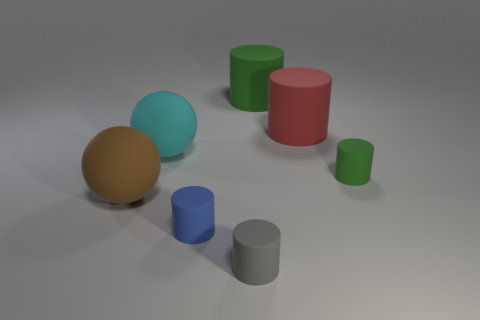How big is the matte cylinder that is in front of the matte cylinder to the left of the small rubber cylinder that is in front of the blue matte thing?
Give a very brief answer. Small. What is the material of the brown object that is the same size as the cyan thing?
Make the answer very short. Rubber. Are there any cylinders that have the same size as the gray matte object?
Offer a terse response. Yes. Does the green matte object that is right of the red rubber cylinder have the same size as the tiny blue matte thing?
Make the answer very short. Yes. There is a rubber thing that is both on the right side of the small gray rubber thing and in front of the large cyan matte object; what shape is it?
Offer a terse response. Cylinder. Are there more small blue matte cylinders that are in front of the blue matte cylinder than shiny balls?
Your response must be concise. No. The gray cylinder that is made of the same material as the blue cylinder is what size?
Keep it short and to the point. Small. Are there the same number of big green things to the left of the big green matte object and cylinders that are behind the red matte cylinder?
Provide a short and direct response. No. There is a object that is to the right of the red thing; what is its color?
Ensure brevity in your answer.  Green. Are there an equal number of tiny gray matte cylinders on the left side of the cyan sphere and green metal cylinders?
Provide a short and direct response. Yes. 